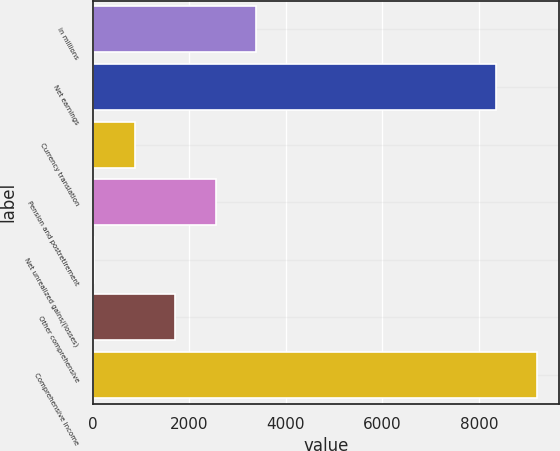Convert chart. <chart><loc_0><loc_0><loc_500><loc_500><bar_chart><fcel>in millions<fcel>Net earnings<fcel>Currency translation<fcel>Pension and postretirement<fcel>Net unrealized gains/(losses)<fcel>Other comprehensive<fcel>Comprehensive income<nl><fcel>3387.6<fcel>8354<fcel>866.4<fcel>2547.2<fcel>26<fcel>1706.8<fcel>9194.4<nl></chart> 